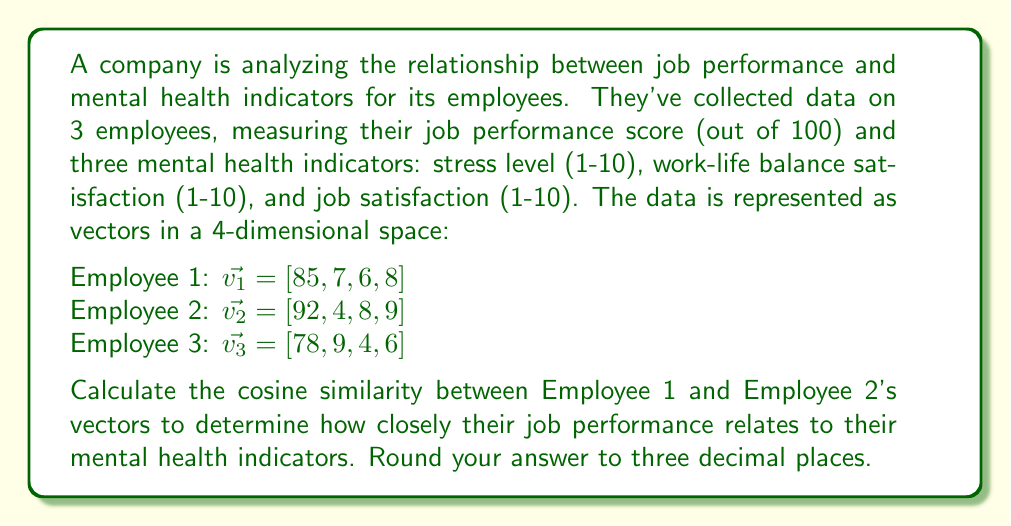Show me your answer to this math problem. To calculate the cosine similarity between two vectors, we use the formula:

$$\text{cosine similarity} = \frac{\vec{v_1} \cdot \vec{v_2}}{\|\vec{v_1}\| \|\vec{v_2}\|}$$

Where $\vec{v_1} \cdot \vec{v_2}$ is the dot product of the vectors, and $\|\vec{v}\|$ is the magnitude (length) of a vector.

Step 1: Calculate the dot product of $\vec{v_1}$ and $\vec{v_2}$:
$\vec{v_1} \cdot \vec{v_2} = (85 \times 92) + (7 \times 4) + (6 \times 8) + (8 \times 9) = 7820 + 28 + 48 + 72 = 7968$

Step 2: Calculate the magnitude of $\vec{v_1}$:
$\|\vec{v_1}\| = \sqrt{85^2 + 7^2 + 6^2 + 8^2} = \sqrt{7225 + 49 + 36 + 64} = \sqrt{7374} \approx 85.871$

Step 3: Calculate the magnitude of $\vec{v_2}$:
$\|\vec{v_2}\| = \sqrt{92^2 + 4^2 + 8^2 + 9^2} = \sqrt{8464 + 16 + 64 + 81} = \sqrt{8625} \approx 92.872$

Step 4: Apply the cosine similarity formula:
$$\text{cosine similarity} = \frac{7968}{85.871 \times 92.872} \approx 0.9994$$

Step 5: Round to three decimal places:
0.999

This high cosine similarity (very close to 1) indicates that Employee 1 and Employee 2 have very similar patterns in their job performance and mental health indicators, despite some differences in individual scores.
Answer: 0.999 